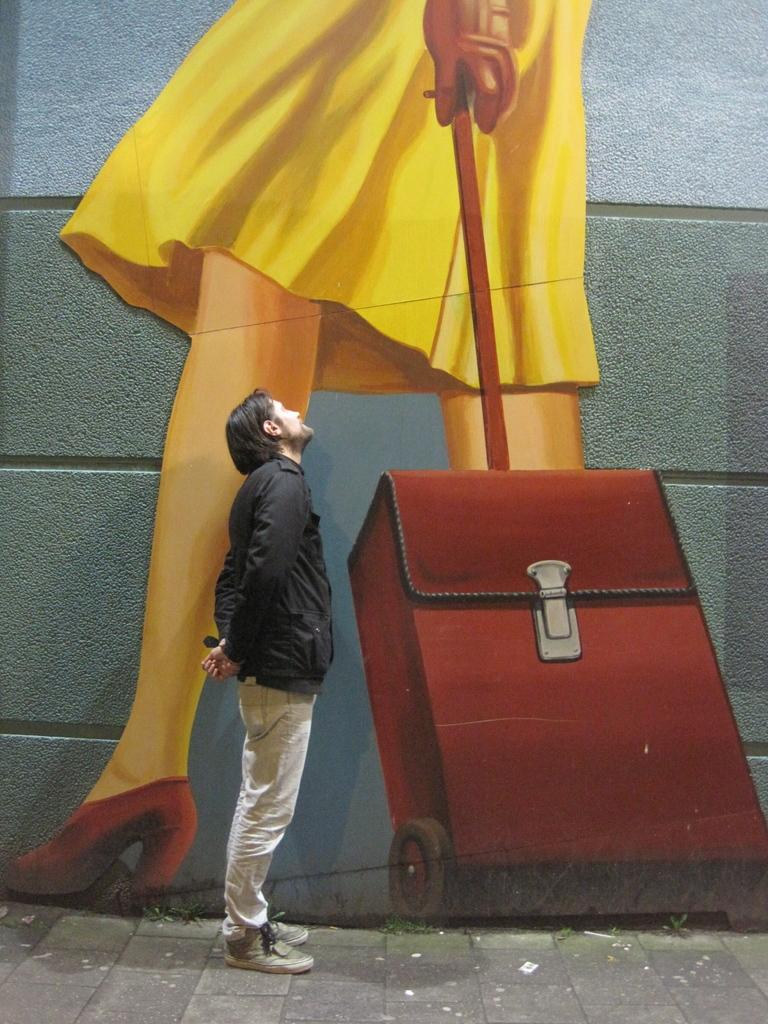What is the person in the image doing? The person is standing on the path in the image. What can be seen in the image besides the person? There are plants visible in the image, as well as a 3D painting and a wall in the background. What is the name of the argument happening in the image? There is no argument present in the image; it only shows a person standing on a path with plants, a 3D painting, and a wall in the background. 